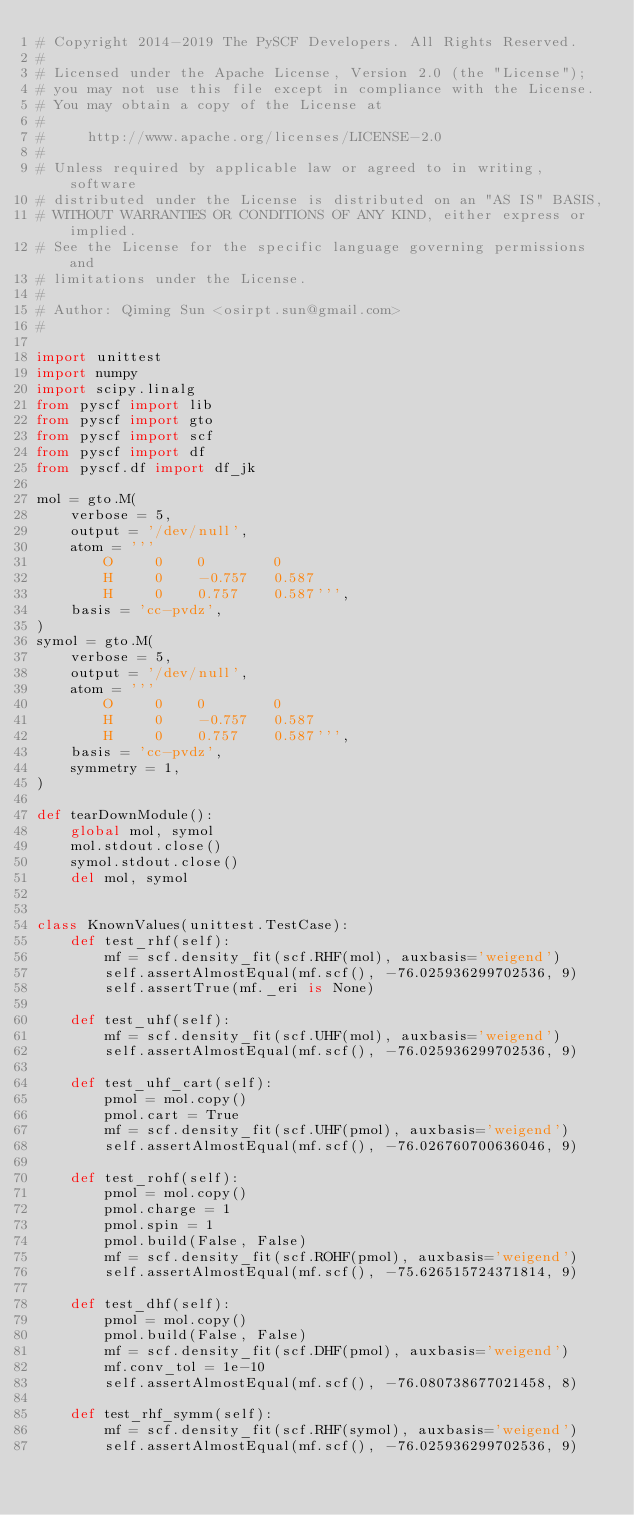Convert code to text. <code><loc_0><loc_0><loc_500><loc_500><_Python_># Copyright 2014-2019 The PySCF Developers. All Rights Reserved.
#
# Licensed under the Apache License, Version 2.0 (the "License");
# you may not use this file except in compliance with the License.
# You may obtain a copy of the License at
#
#     http://www.apache.org/licenses/LICENSE-2.0
#
# Unless required by applicable law or agreed to in writing, software
# distributed under the License is distributed on an "AS IS" BASIS,
# WITHOUT WARRANTIES OR CONDITIONS OF ANY KIND, either express or implied.
# See the License for the specific language governing permissions and
# limitations under the License.
#
# Author: Qiming Sun <osirpt.sun@gmail.com>
#

import unittest
import numpy
import scipy.linalg
from pyscf import lib
from pyscf import gto
from pyscf import scf
from pyscf import df
from pyscf.df import df_jk

mol = gto.M(
    verbose = 5,
    output = '/dev/null',
    atom = '''
        O     0    0        0
        H     0    -0.757   0.587
        H     0    0.757    0.587''',
    basis = 'cc-pvdz',
)
symol = gto.M(
    verbose = 5,
    output = '/dev/null',
    atom = '''
        O     0    0        0
        H     0    -0.757   0.587
        H     0    0.757    0.587''',
    basis = 'cc-pvdz',
    symmetry = 1,
)

def tearDownModule():
    global mol, symol
    mol.stdout.close()
    symol.stdout.close()
    del mol, symol


class KnownValues(unittest.TestCase):
    def test_rhf(self):
        mf = scf.density_fit(scf.RHF(mol), auxbasis='weigend')
        self.assertAlmostEqual(mf.scf(), -76.025936299702536, 9)
        self.assertTrue(mf._eri is None)

    def test_uhf(self):
        mf = scf.density_fit(scf.UHF(mol), auxbasis='weigend')
        self.assertAlmostEqual(mf.scf(), -76.025936299702536, 9)

    def test_uhf_cart(self):
        pmol = mol.copy()
        pmol.cart = True
        mf = scf.density_fit(scf.UHF(pmol), auxbasis='weigend')
        self.assertAlmostEqual(mf.scf(), -76.026760700636046, 9)

    def test_rohf(self):
        pmol = mol.copy()
        pmol.charge = 1
        pmol.spin = 1
        pmol.build(False, False)
        mf = scf.density_fit(scf.ROHF(pmol), auxbasis='weigend')
        self.assertAlmostEqual(mf.scf(), -75.626515724371814, 9)

    def test_dhf(self):
        pmol = mol.copy()
        pmol.build(False, False)
        mf = scf.density_fit(scf.DHF(pmol), auxbasis='weigend')
        mf.conv_tol = 1e-10
        self.assertAlmostEqual(mf.scf(), -76.080738677021458, 8)

    def test_rhf_symm(self):
        mf = scf.density_fit(scf.RHF(symol), auxbasis='weigend')
        self.assertAlmostEqual(mf.scf(), -76.025936299702536, 9)
</code> 